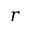<formula> <loc_0><loc_0><loc_500><loc_500>{ r }</formula> 